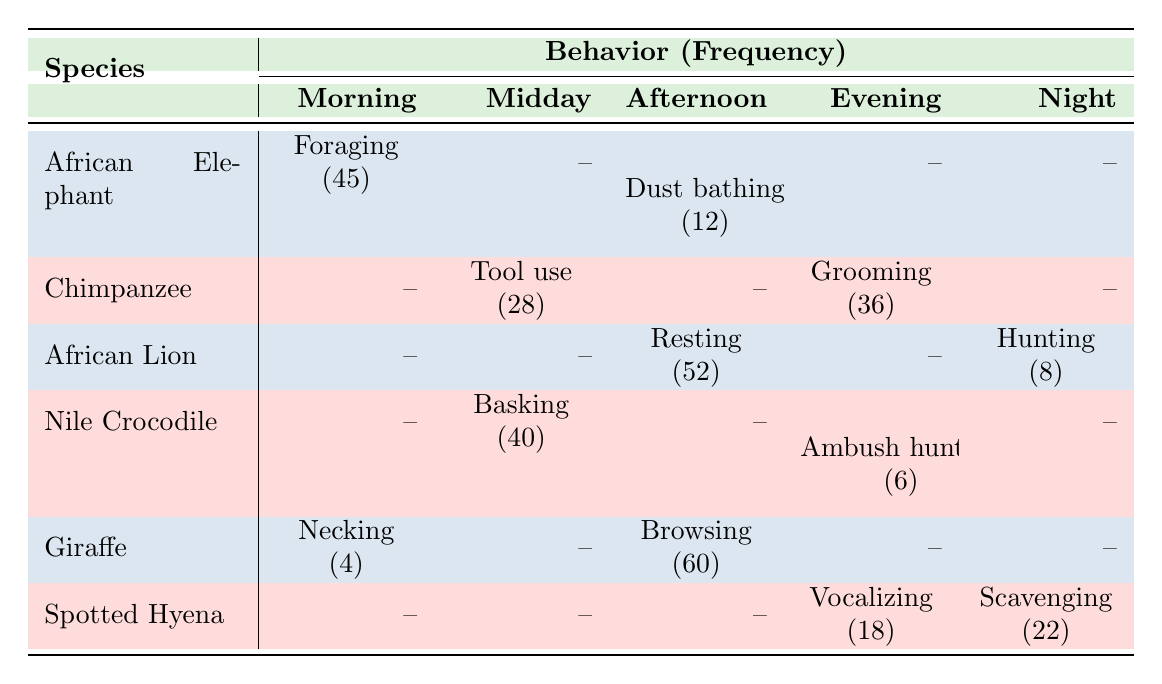What behavior is most frequently observed in African Elephants? The behavior with the highest frequency for African Elephants is Foraging, with a frequency of 45, compared to Dust bathing which has a frequency of 12.
Answer: Foraging How many behaviors are documented for Giraffes? There are two behaviors documented for Giraffes: Necking (4) and Browsing (60), giving a total of two distinct behaviors.
Answer: 2 Which species has the highest frequency of behavior during the afternoon? Giraffe has the highest frequency during the afternoon with Browsing at a frequency of 60, which is higher than Dust bathing (12) in African Elephants and Resting (52) in African Lions.
Answer: Giraffe Is there any species that exhibits a behavior at night? Yes, both African Lions (Hunting) and Spotted Hyenas (Scavenging) exhibit behaviors at night.
Answer: Yes What is the total frequency of behaviors documented for Chimpanzees? The total frequency for Chimpanzees is calculated by adding the frequencies of Tool use (28) and Grooming (36), resulting in a total of 64.
Answer: 64 Which behavior has the lowest frequency and during what time of day? The behavior with the lowest frequency is Necking (4) in Giraffes during the morning.
Answer: Necking How does the frequency of Scavenging compare to Grooming? Scavenging has a frequency of 22, while Grooming has a frequency of 36. Since Grooming is higher, Scavenging is less frequent than Grooming.
Answer: Scavenging is less frequent than Grooming What is the average frequency of behaviors documented for the Nile Crocodile? There are two behaviors documented: Basking (40) and Ambush hunting (6). The average frequency is calculated as (40 + 6) / 2 = 23.
Answer: 23 How many species exhibit behaviors during the midday? There are three species that exhibit behaviors during midday: Chimpanzees (Tool use), Nile Crocodiles (Basking), and the Giraffe (none). Thus, it counts as two species.
Answer: 2 